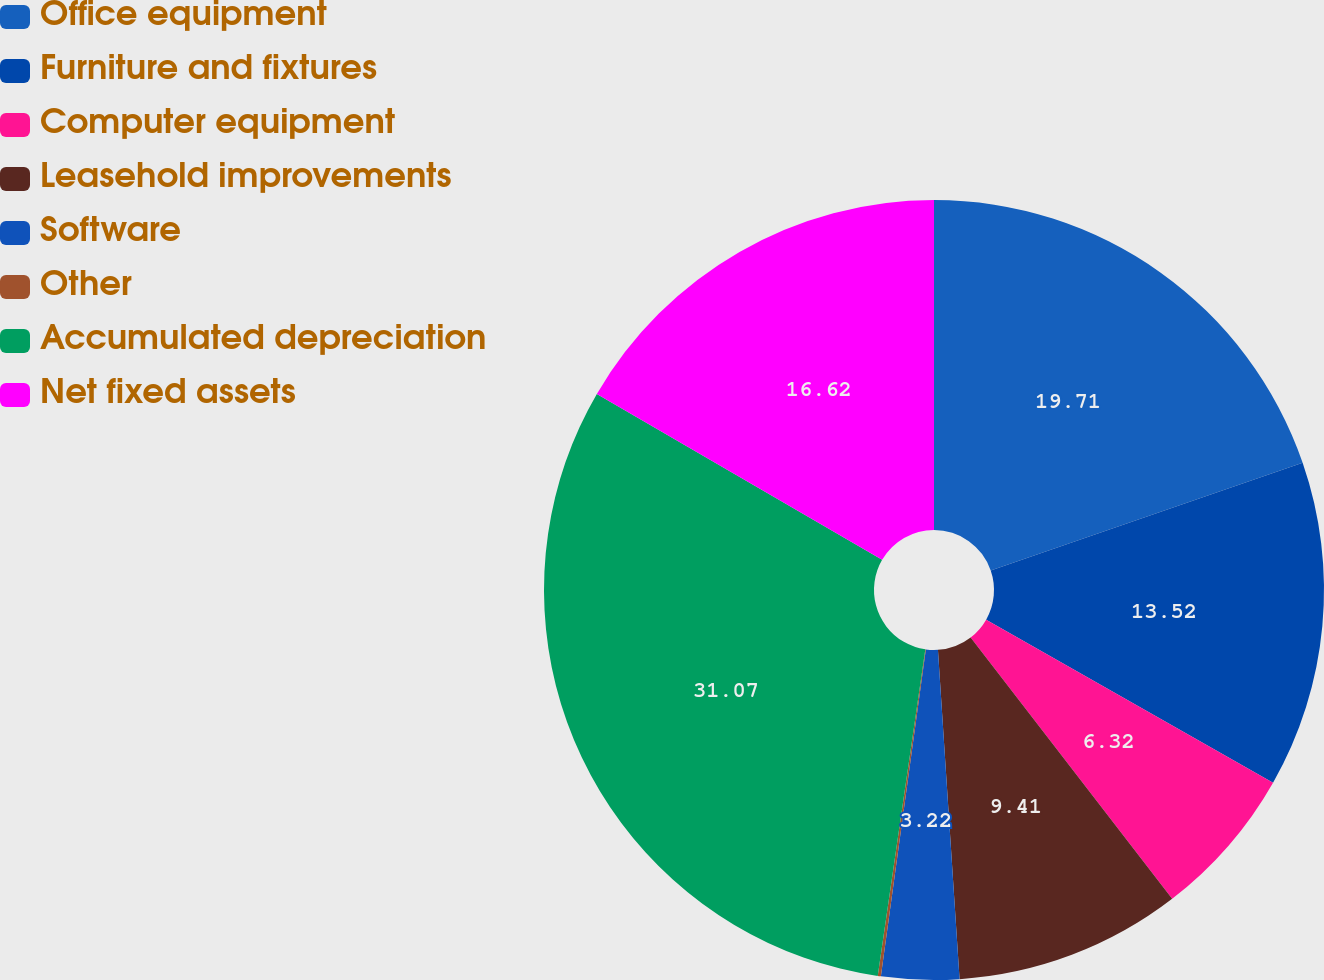Convert chart. <chart><loc_0><loc_0><loc_500><loc_500><pie_chart><fcel>Office equipment<fcel>Furniture and fixtures<fcel>Computer equipment<fcel>Leasehold improvements<fcel>Software<fcel>Other<fcel>Accumulated depreciation<fcel>Net fixed assets<nl><fcel>19.71%<fcel>13.52%<fcel>6.32%<fcel>9.41%<fcel>3.22%<fcel>0.13%<fcel>31.08%<fcel>16.62%<nl></chart> 